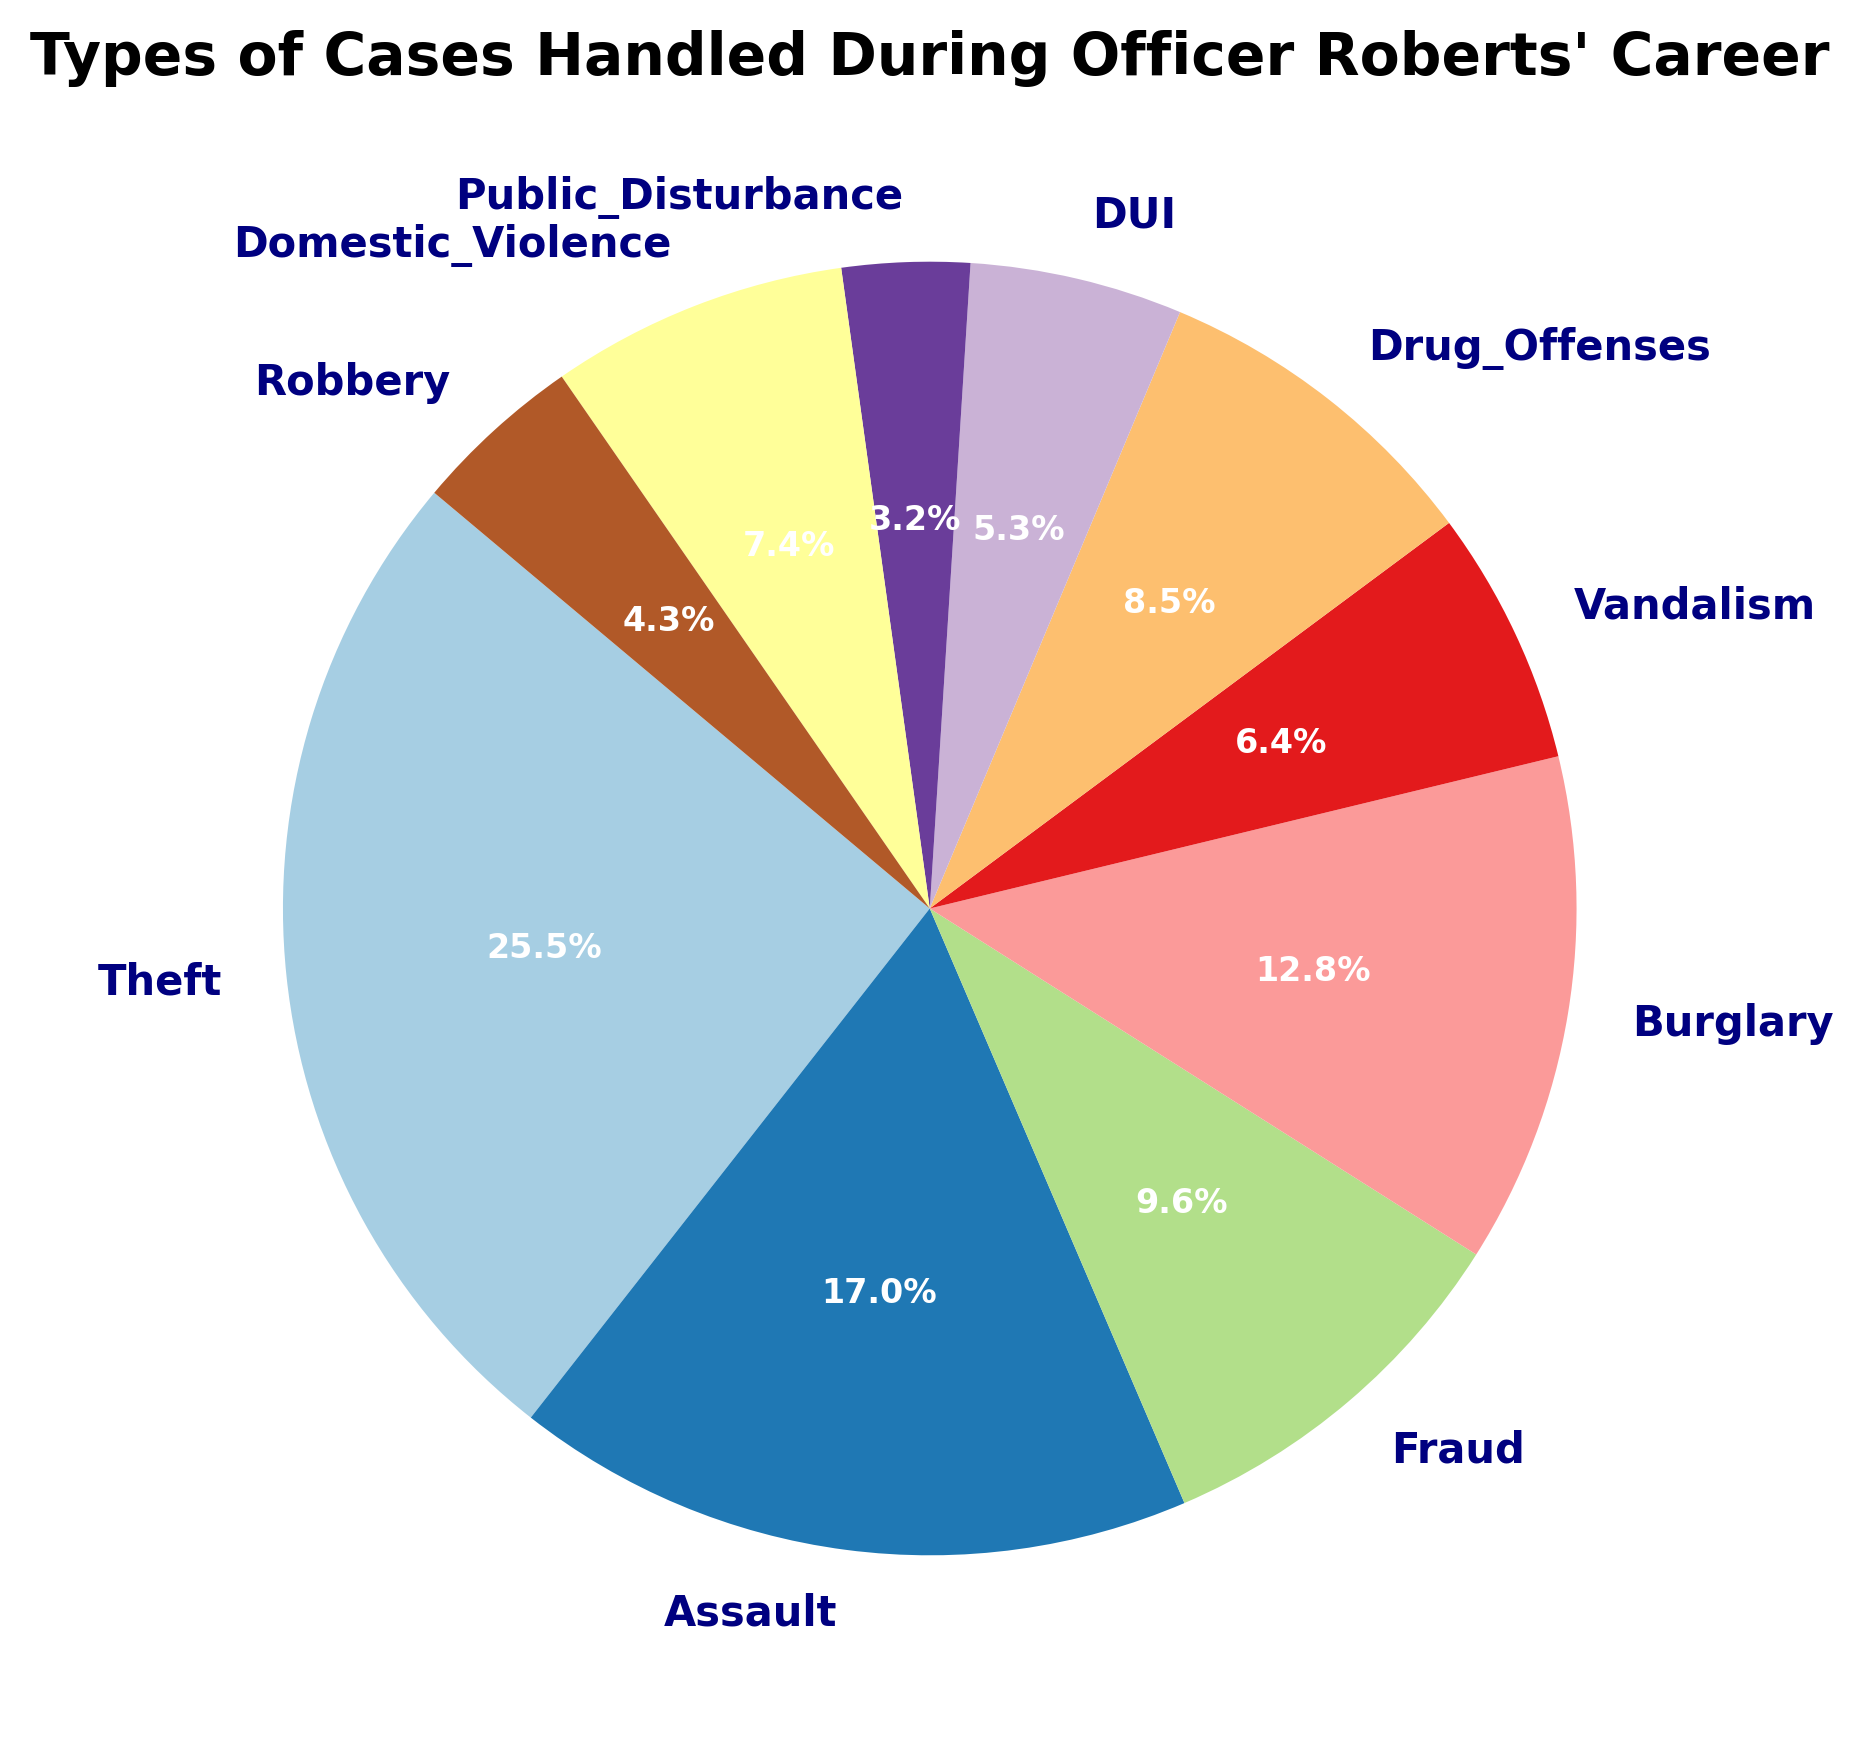What percentage of total cases does theft represent? Find the segment labeled "Theft" on the pie chart. The corresponding percentage is provided inside or next to the segment.
Answer: 30.8% Which crime category has the second highest number of cases? Examine the slices of the pie chart to identify which one is the second largest. The segment labeled "Assault" follows the largest one, "Theft".
Answer: Assault How many more cases of theft were there compared to robbery? Find the values for both theft (120) and robbery (20), then subtract the number of robbery cases from the number of theft cases: 120 - 20.
Answer: 100 What is the combined percentage of drug offenses and DUI cases? Find the percentages for drug offenses (40 cases) and DUI (25 cases). Add the percentages: 10.3% (drug offenses) + 6.4% (DUI).
Answer: 16.7% Which crime category had the smallest number of cases? Identify the smallest segment on the pie chart. The segment labeled "Public Disturbance" is the smallest.
Answer: Public Disturbance How does the number of domestic violence cases compare to vandalism cases? Find the values for domestic violence (35) and vandalism (30). Determine the comparison by noting if 35 is greater than, less than, or equal to 30.
Answer: Domestic violence > Vandalism Which categories cumulatively make up more than half of the total cases? Identify the largest segments and add their corresponding percentages until the sum exceeds 50%. Categories are Theft (30.8%), Assault (20.5%), and Burglary (15.4%). Combined sum is 66.7%.
Answer: Theft, Assault, Burglary What is the average number of cases per crime category? Sum all the cases and divide by the number of categories. The sum is 470, and there are 10 categories, so 470 / 10.
Answer: 47 By what factor do theft cases exceed public disturbance cases? Find values for theft (120) and public disturbance (15). Calculate the factor by dividing 120 by 15.
Answer: 8 How do the percentages of fraud and burglary compare visually? Examine the sizes of the slices for fraud and burglary. Observe which slice appears larger or if they look similar. Burglary is larger at 15.4% compared to fraud's 11.5%.
Answer: Burglary > Fraud 